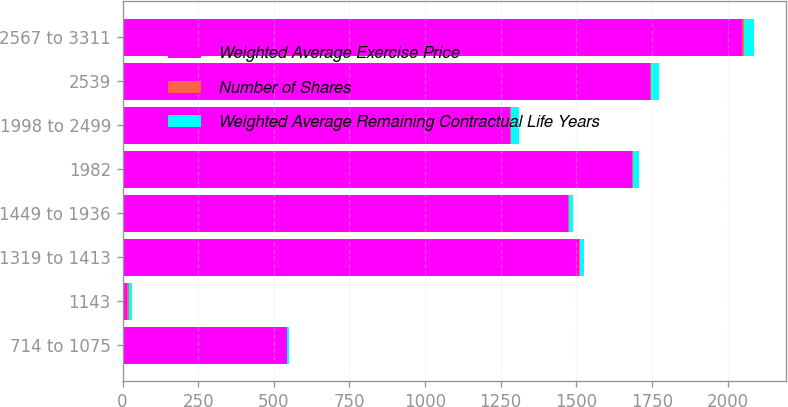Convert chart. <chart><loc_0><loc_0><loc_500><loc_500><stacked_bar_chart><ecel><fcel>714 to 1075<fcel>1143<fcel>1319 to 1413<fcel>1449 to 1936<fcel>1982<fcel>1998 to 2499<fcel>2539<fcel>2567 to 3311<nl><fcel>Weighted Average Exercise Price<fcel>543<fcel>15.85<fcel>1510<fcel>1472<fcel>1685<fcel>1282<fcel>1743<fcel>2049<nl><fcel>Number of Shares<fcel>1.1<fcel>4.1<fcel>3<fcel>2<fcel>3.1<fcel>2.2<fcel>5.1<fcel>6<nl><fcel>Weighted Average Remaining Contractual Life Years<fcel>7.31<fcel>11.43<fcel>13.45<fcel>15.85<fcel>19.82<fcel>24.78<fcel>25.39<fcel>32.37<nl></chart> 